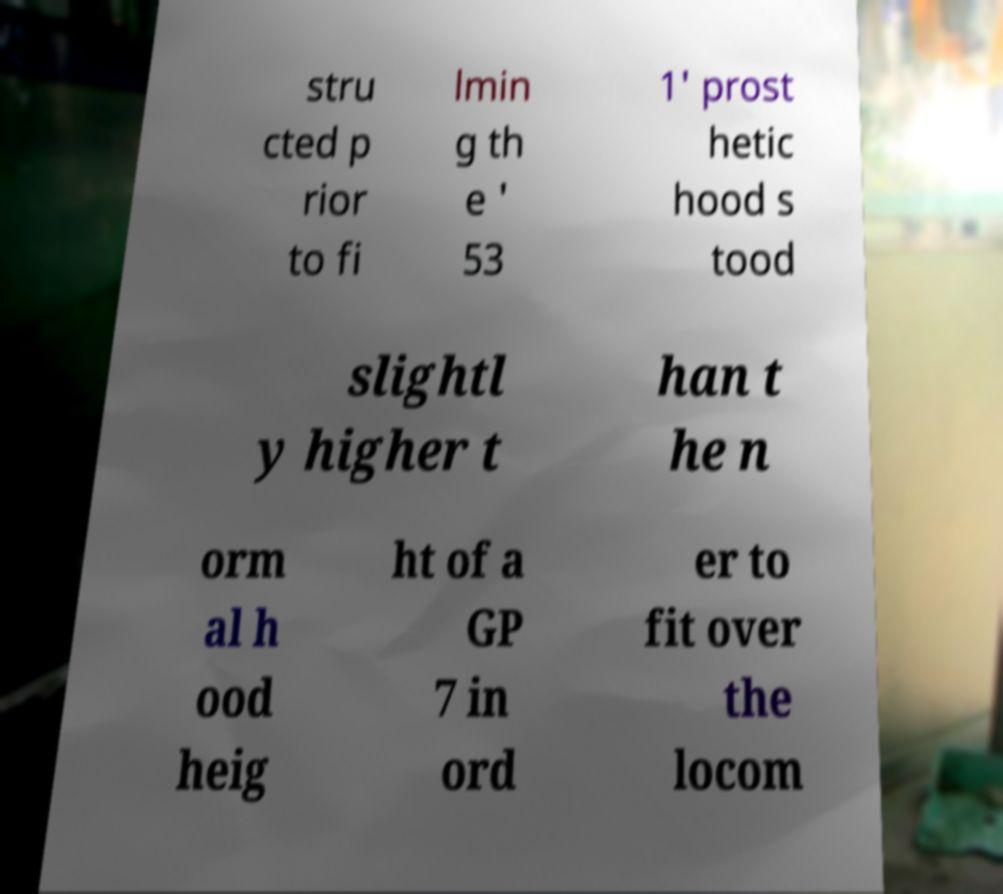There's text embedded in this image that I need extracted. Can you transcribe it verbatim? stru cted p rior to fi lmin g th e ' 53 1' prost hetic hood s tood slightl y higher t han t he n orm al h ood heig ht of a GP 7 in ord er to fit over the locom 